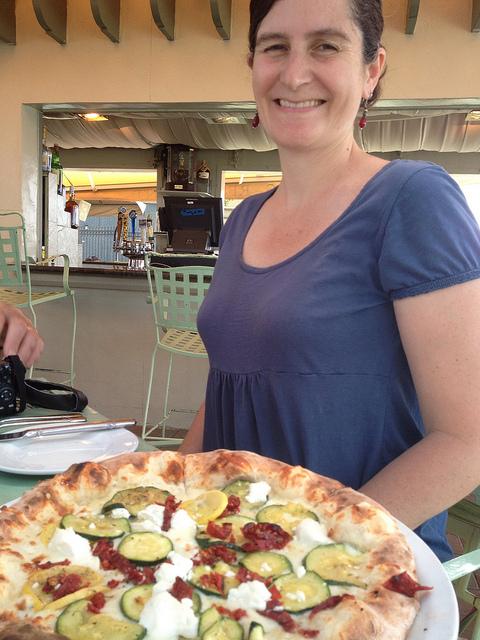Is this a dress?
Give a very brief answer. No. What is this food?
Concise answer only. Pizza. Is she a pizza baker?
Keep it brief. Yes. Is this person wearing glasses?
Give a very brief answer. No. 